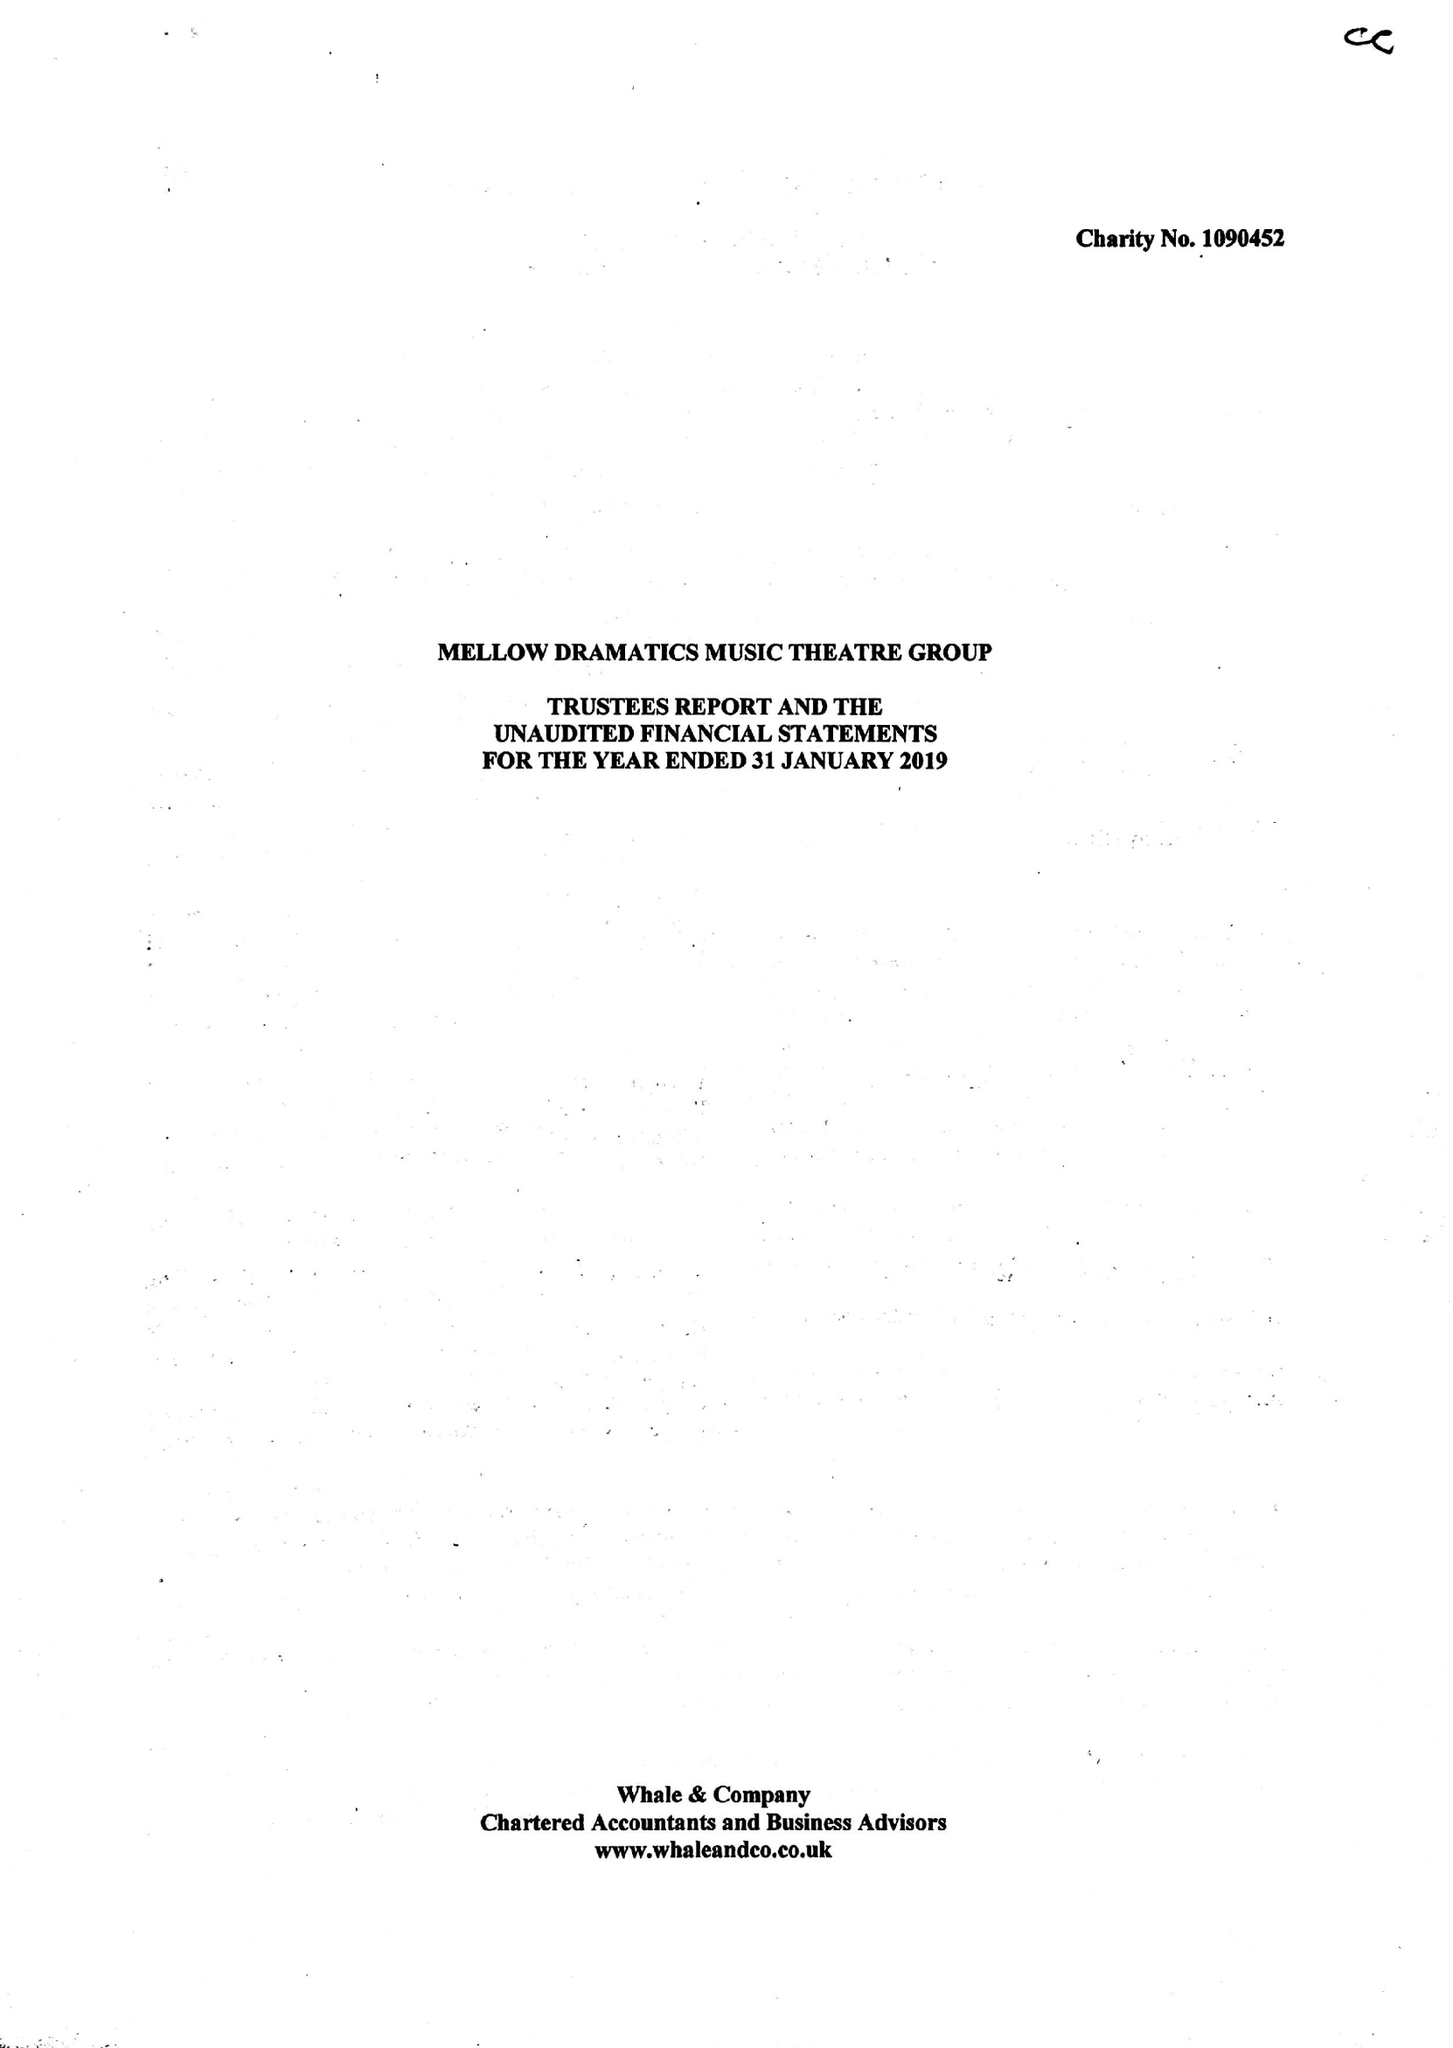What is the value for the spending_annually_in_british_pounds?
Answer the question using a single word or phrase. 52327.00 